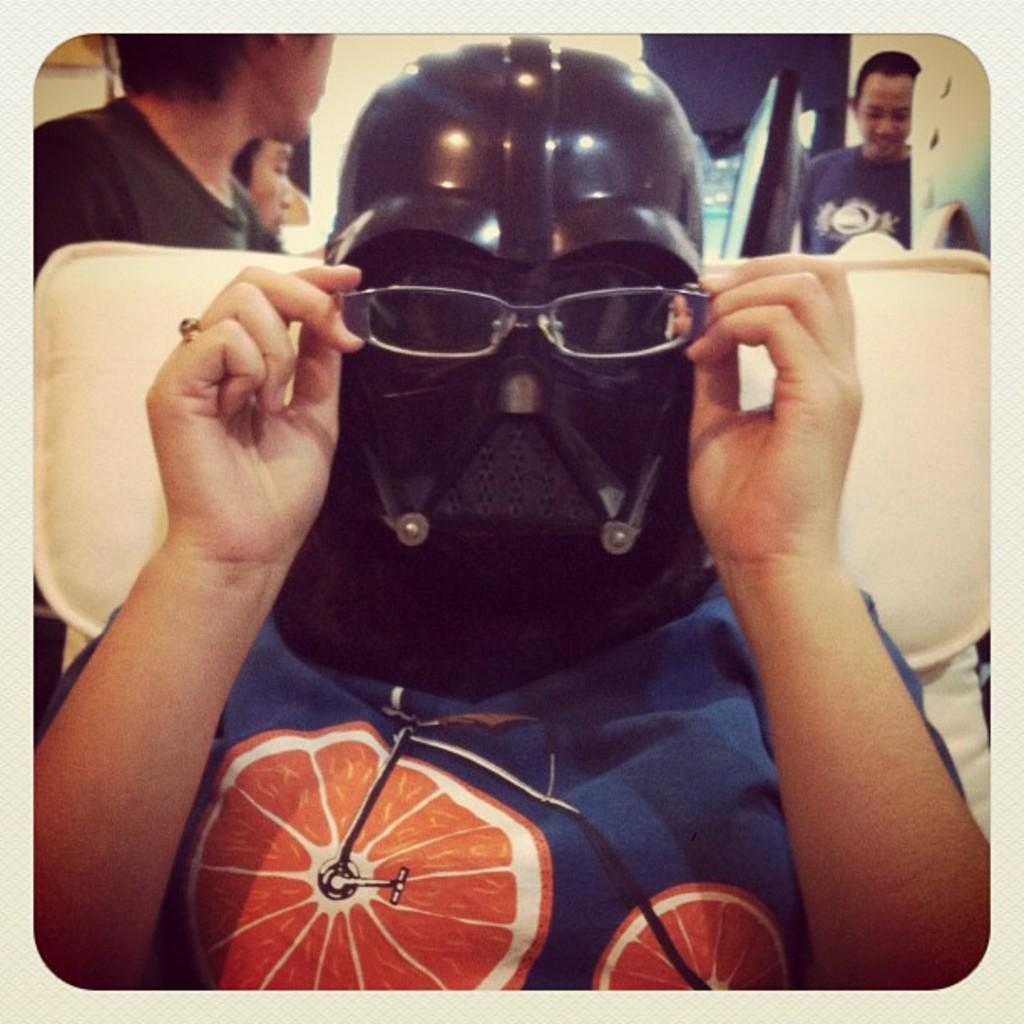How many people are in the image? There are people in the image, but the exact number is not specified. What is the person in the front wearing? The person in the front is wearing a helmet. What is the person in the front holding? The person in the front is holding spectacles in their hands. What can be seen in the background of the image? There are other objects visible in the background of the image, but their specific nature is not mentioned. How many bears are visible in the image? There are no bears present in the image. What is the person in the front feeling in the image? The facts provided do not give any information about the emotions or feelings of the person in the front, so it cannot be determined from the image. 